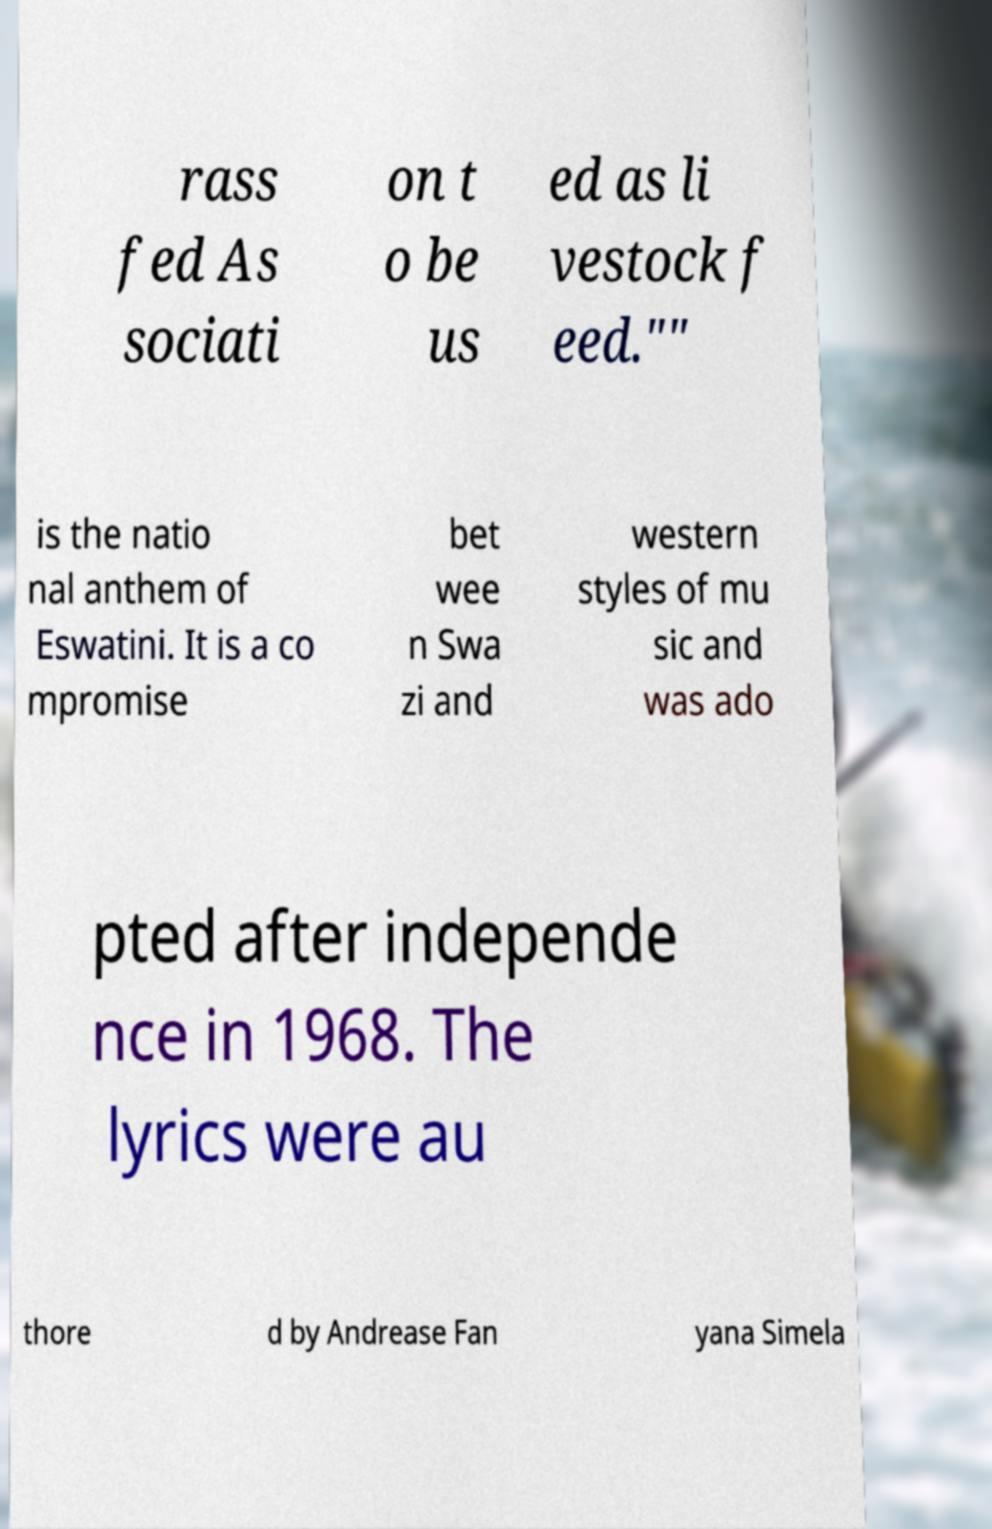Could you assist in decoding the text presented in this image and type it out clearly? rass fed As sociati on t o be us ed as li vestock f eed."" is the natio nal anthem of Eswatini. It is a co mpromise bet wee n Swa zi and western styles of mu sic and was ado pted after independe nce in 1968. The lyrics were au thore d by Andrease Fan yana Simela 